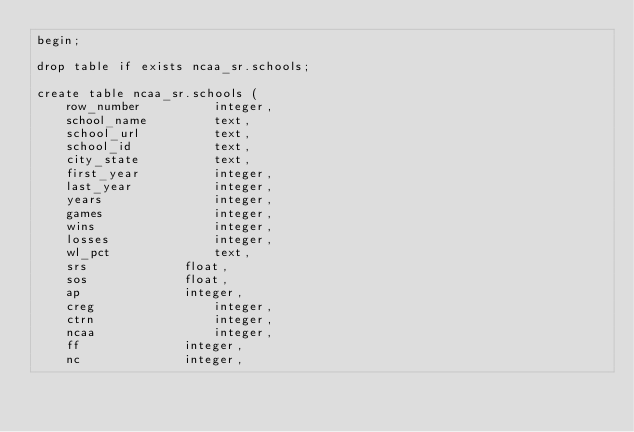<code> <loc_0><loc_0><loc_500><loc_500><_SQL_>begin;

drop table if exists ncaa_sr.schools;

create table ncaa_sr.schools (
	row_number			integer,
	school_name			text,
	school_url			text,
	school_id			text,
	city_state			text,
	first_year			integer,
	last_year			integer,
	years				integer,
	games				integer,
	wins				integer,
	losses				integer,
	wl_pct				text,
	srs				float,
	sos				float,
	ap				integer,
	creg				integer,
	ctrn				integer,
	ncaa				integer,
	ff				integer,
	nc				integer,</code> 